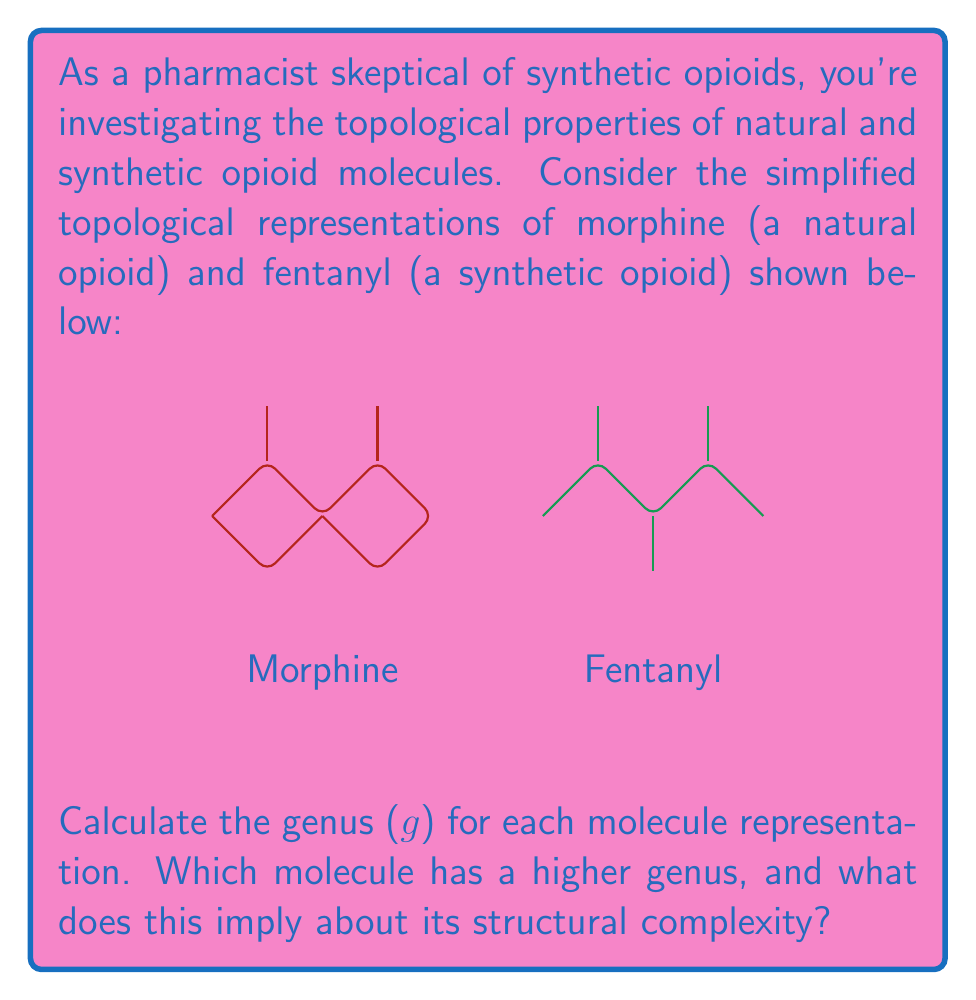Can you solve this math problem? To solve this problem, we need to understand and apply the concept of genus in topology:

1. The genus (g) of a surface is the maximum number of simple closed curves that can be drawn on the surface without separating it.

2. For planar graphs, we can use Euler's formula: $V - E + F = 2 - 2g$, where V is the number of vertices, E is the number of edges, and F is the number of faces (including the outer face).

3. Let's analyze each molecule:

Morphine:
- Vertices (V): 9
- Edges (E): 10
- Faces (F): We need to count the regions, including the outer face: 3

Using Euler's formula:
$9 - 10 + 3 = 2 - 2g$
$2 = 2 - 2g$
$2g = 0$
$g = 0$

Fentanyl:
- Vertices (V): 7
- Edges (E): 7
- Faces (F): We need to count the regions, including the outer face: 2

Using Euler's formula:
$7 - 7 + 2 = 2 - 2g$
$2 = 2 - 2g$
$2g = 0$
$g = 0$

4. Both molecules have a genus of 0, which means they are both planar graphs and can be drawn on a plane without any edge crossings.

5. In terms of structural complexity, the genus alone doesn't provide a complete picture. While both have the same genus, morphine has more vertices and edges, suggesting a more complex structure in terms of connectivity.
Answer: Both have genus 0; morphine is more complex based on vertex and edge count. 